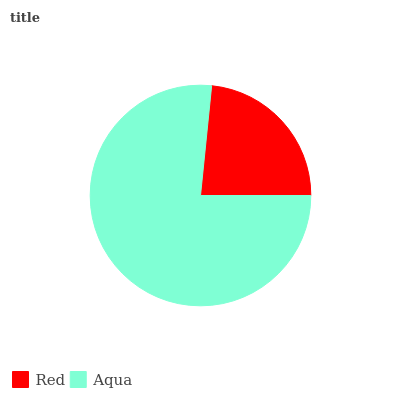Is Red the minimum?
Answer yes or no. Yes. Is Aqua the maximum?
Answer yes or no. Yes. Is Aqua the minimum?
Answer yes or no. No. Is Aqua greater than Red?
Answer yes or no. Yes. Is Red less than Aqua?
Answer yes or no. Yes. Is Red greater than Aqua?
Answer yes or no. No. Is Aqua less than Red?
Answer yes or no. No. Is Aqua the high median?
Answer yes or no. Yes. Is Red the low median?
Answer yes or no. Yes. Is Red the high median?
Answer yes or no. No. Is Aqua the low median?
Answer yes or no. No. 